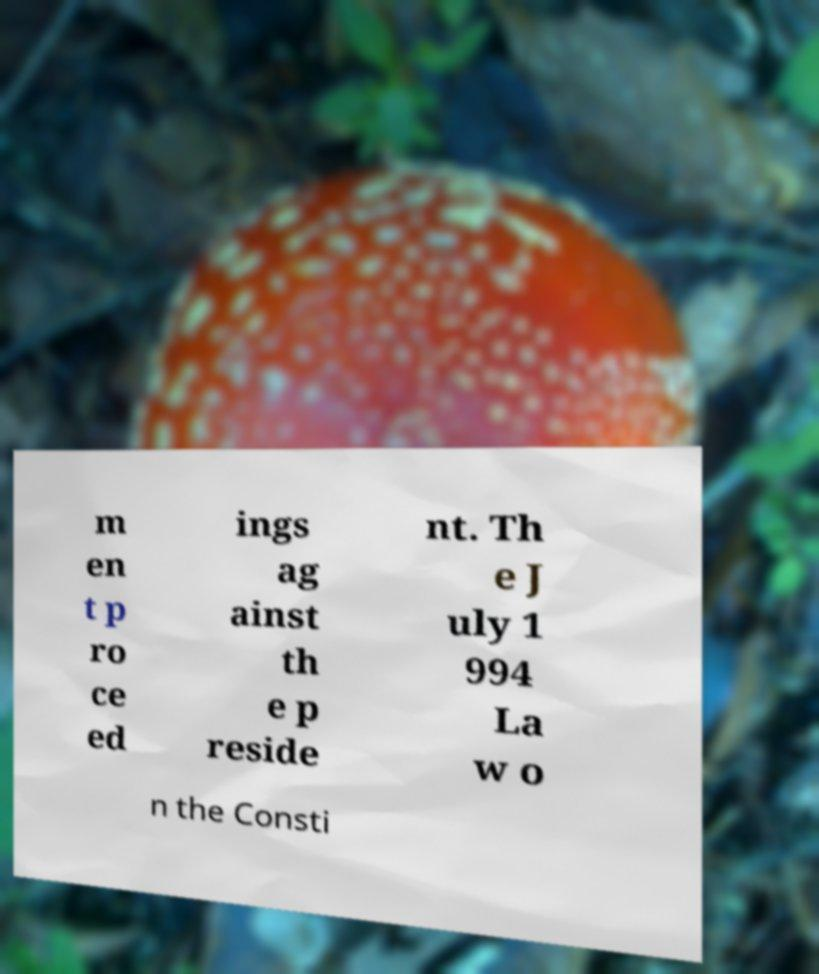There's text embedded in this image that I need extracted. Can you transcribe it verbatim? m en t p ro ce ed ings ag ainst th e p reside nt. Th e J uly 1 994 La w o n the Consti 